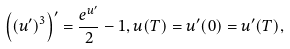Convert formula to latex. <formula><loc_0><loc_0><loc_500><loc_500>\left ( ( u ^ { \prime } ) ^ { 3 } \right ) ^ { \prime } = \frac { e ^ { u ^ { \prime } } } { 2 } - 1 , u ( T ) = u ^ { \prime } ( 0 ) = u ^ { \prime } ( T ) ,</formula> 